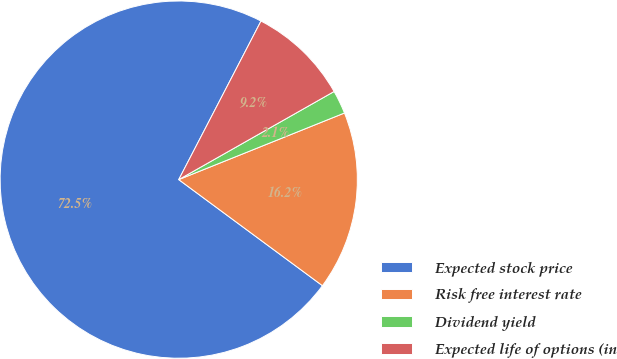<chart> <loc_0><loc_0><loc_500><loc_500><pie_chart><fcel>Expected stock price<fcel>Risk free interest rate<fcel>Dividend yield<fcel>Expected life of options (in<nl><fcel>72.49%<fcel>16.2%<fcel>2.13%<fcel>9.17%<nl></chart> 